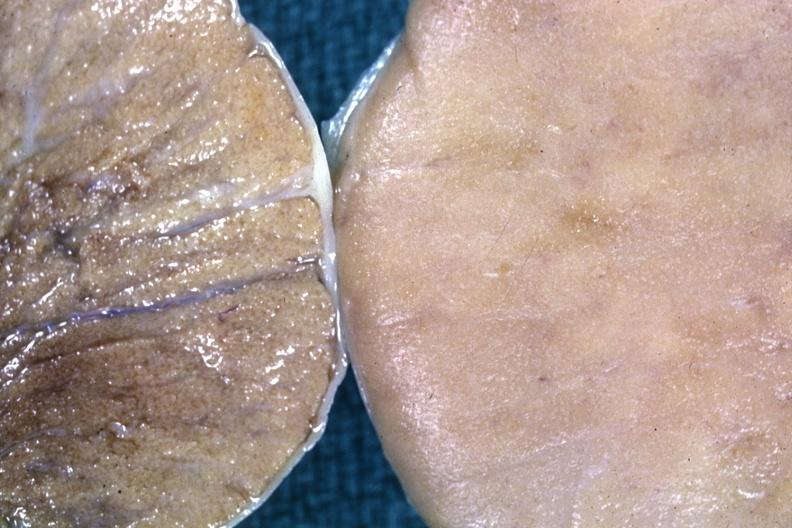what is present?
Answer the question using a single word or phrase. Malignant lymphoma 